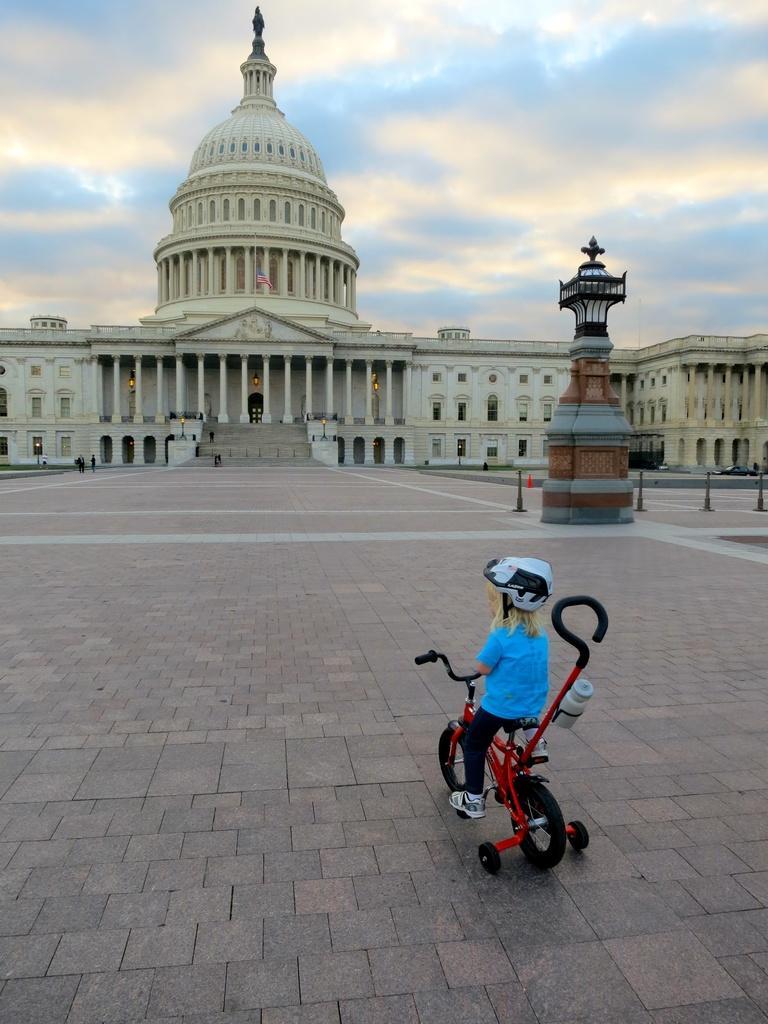Can you describe this image briefly? In this image in front there is a girl sitting on the cycle. On the right side of the image there is a memorial. There are poles. In the center of the image there are stairs. In the background of the image there are people standing on the floor. There are buildings, lights. At the top of the image there is sky. 